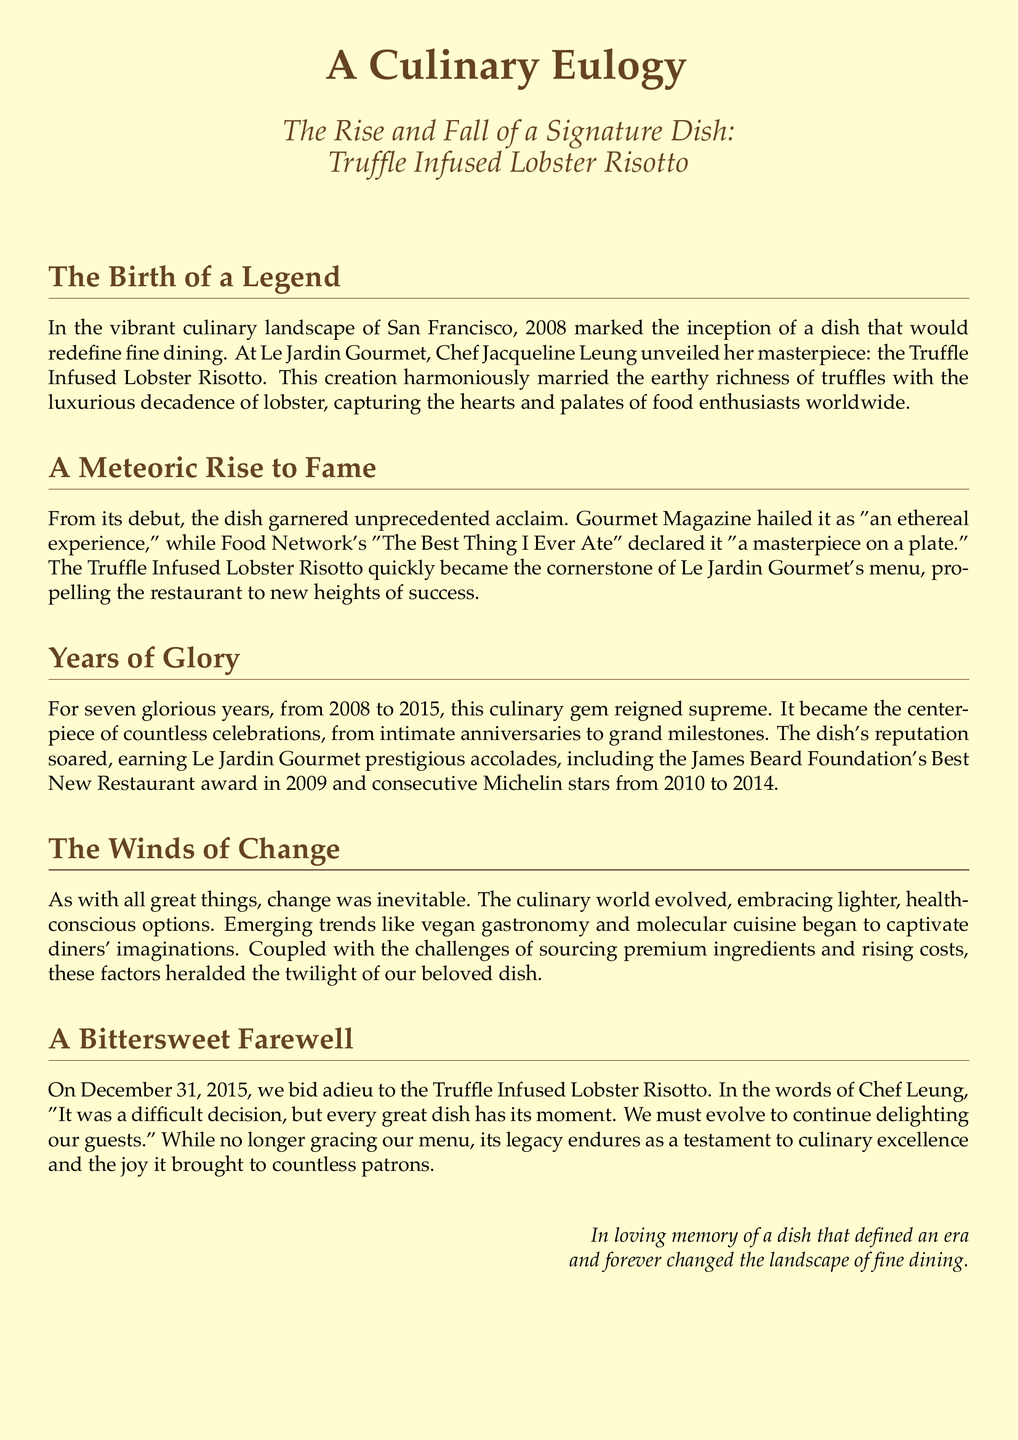What year was the dish introduced? The document states that the dish was introduced in 2008.
Answer: 2008 Who is the chef behind the signature dish? The chef mentioned in the document as the creator of the dish is Chef Jacqueline Leung.
Answer: Chef Jacqueline Leung What prestigious award did Le Jardin Gourmet receive in 2009? The document highlights that Le Jardin Gourmet received the James Beard Foundation's Best New Restaurant award in 2009.
Answer: Best New Restaurant How many years did the Truffle Infused Lobster Risotto remain on the menu? The text indicates that the dish reigned supreme for seven years.
Answer: Seven years What culinary trend began to impact the dish's popularity? The document mentions emerging trends like vegan gastronomy affecting the dish's popularity.
Answer: Vegan gastronomy What was the final date the dish was served? According to the document, the dish was last served on December 31, 2015.
Answer: December 31, 2015 What kind of dining experience did Gourmet Magazine describe the dish as? The magazine described it as "an ethereal experience."
Answer: An ethereal experience Why was the dish ultimately removed from the menu? The document details that the removal was due to evolving culinary trends and challenges in sourcing ingredients.
Answer: Evolving culinary trends What does the eulogy signify about the dish? The eulogy signifies the dish as a testament to culinary excellence and its significant impact.
Answer: Testament to culinary excellence 